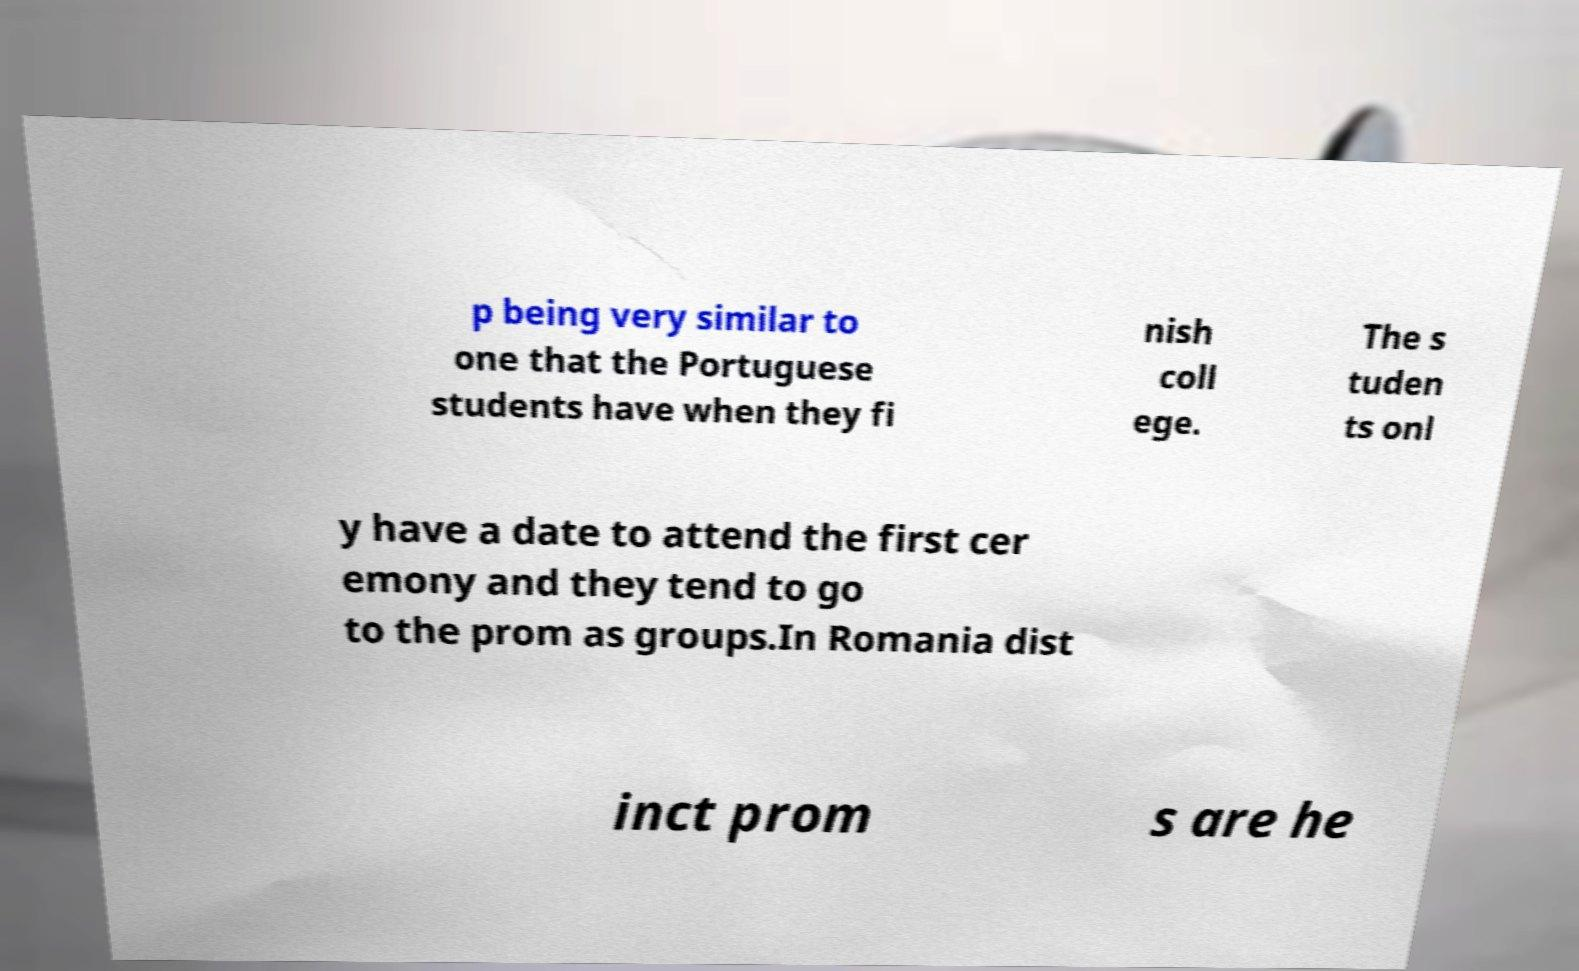Can you read and provide the text displayed in the image?This photo seems to have some interesting text. Can you extract and type it out for me? p being very similar to one that the Portuguese students have when they fi nish coll ege. The s tuden ts onl y have a date to attend the first cer emony and they tend to go to the prom as groups.In Romania dist inct prom s are he 